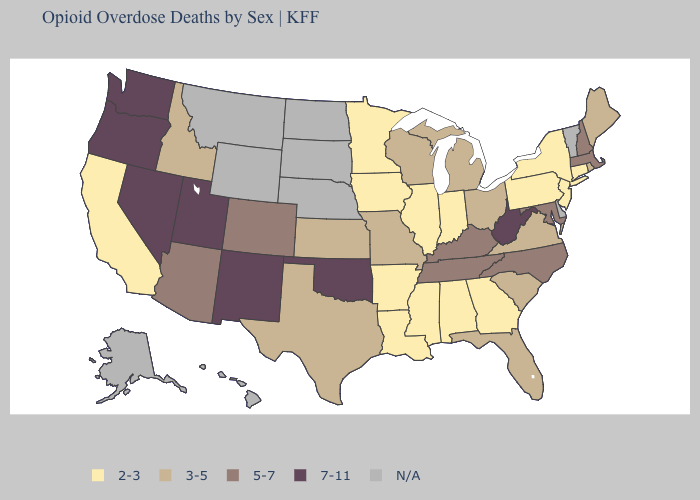Does Utah have the highest value in the West?
Short answer required. Yes. What is the value of New Mexico?
Quick response, please. 7-11. What is the lowest value in the USA?
Quick response, please. 2-3. Name the states that have a value in the range 7-11?
Short answer required. Nevada, New Mexico, Oklahoma, Oregon, Utah, Washington, West Virginia. Does Pennsylvania have the lowest value in the USA?
Keep it brief. Yes. What is the value of New Jersey?
Concise answer only. 2-3. What is the value of Alabama?
Keep it brief. 2-3. Does Oklahoma have the highest value in the South?
Short answer required. Yes. Name the states that have a value in the range N/A?
Answer briefly. Alaska, Delaware, Hawaii, Montana, Nebraska, North Dakota, South Dakota, Vermont, Wyoming. What is the value of Idaho?
Give a very brief answer. 3-5. What is the highest value in the MidWest ?
Concise answer only. 3-5. Does Minnesota have the highest value in the USA?
Answer briefly. No. Among the states that border South Dakota , which have the lowest value?
Short answer required. Iowa, Minnesota. Does the first symbol in the legend represent the smallest category?
Concise answer only. Yes. 